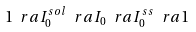Convert formula to latex. <formula><loc_0><loc_0><loc_500><loc_500>1 \ r a I _ { 0 } ^ { s o l } \ r a I _ { 0 } \ r a I _ { 0 } ^ { s s } \ r a 1</formula> 